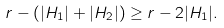<formula> <loc_0><loc_0><loc_500><loc_500>r - ( | H _ { 1 } | + | H _ { 2 } | ) \geq r - 2 | H _ { 1 } | .</formula> 